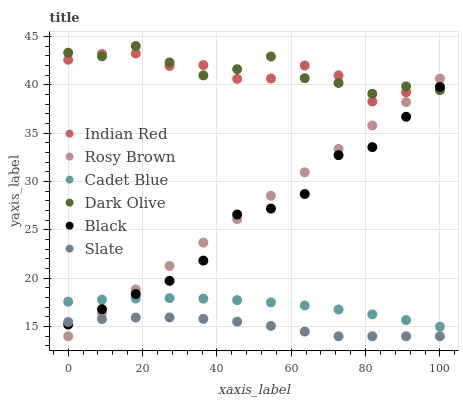Does Slate have the minimum area under the curve?
Answer yes or no. Yes. Does Dark Olive have the maximum area under the curve?
Answer yes or no. Yes. Does Dark Olive have the minimum area under the curve?
Answer yes or no. No. Does Slate have the maximum area under the curve?
Answer yes or no. No. Is Rosy Brown the smoothest?
Answer yes or no. Yes. Is Black the roughest?
Answer yes or no. Yes. Is Dark Olive the smoothest?
Answer yes or no. No. Is Dark Olive the roughest?
Answer yes or no. No. Does Slate have the lowest value?
Answer yes or no. Yes. Does Dark Olive have the lowest value?
Answer yes or no. No. Does Dark Olive have the highest value?
Answer yes or no. Yes. Does Slate have the highest value?
Answer yes or no. No. Is Slate less than Cadet Blue?
Answer yes or no. Yes. Is Indian Red greater than Cadet Blue?
Answer yes or no. Yes. Does Rosy Brown intersect Indian Red?
Answer yes or no. Yes. Is Rosy Brown less than Indian Red?
Answer yes or no. No. Is Rosy Brown greater than Indian Red?
Answer yes or no. No. Does Slate intersect Cadet Blue?
Answer yes or no. No. 